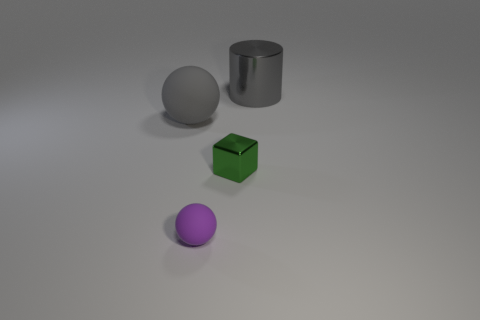Add 1 gray matte things. How many objects exist? 5 Subtract all cylinders. How many objects are left? 3 Add 2 tiny green things. How many tiny green things exist? 3 Subtract 0 yellow cylinders. How many objects are left? 4 Subtract all red balls. Subtract all red blocks. How many balls are left? 2 Subtract all tiny purple rubber things. Subtract all large gray cylinders. How many objects are left? 2 Add 2 small purple balls. How many small purple balls are left? 3 